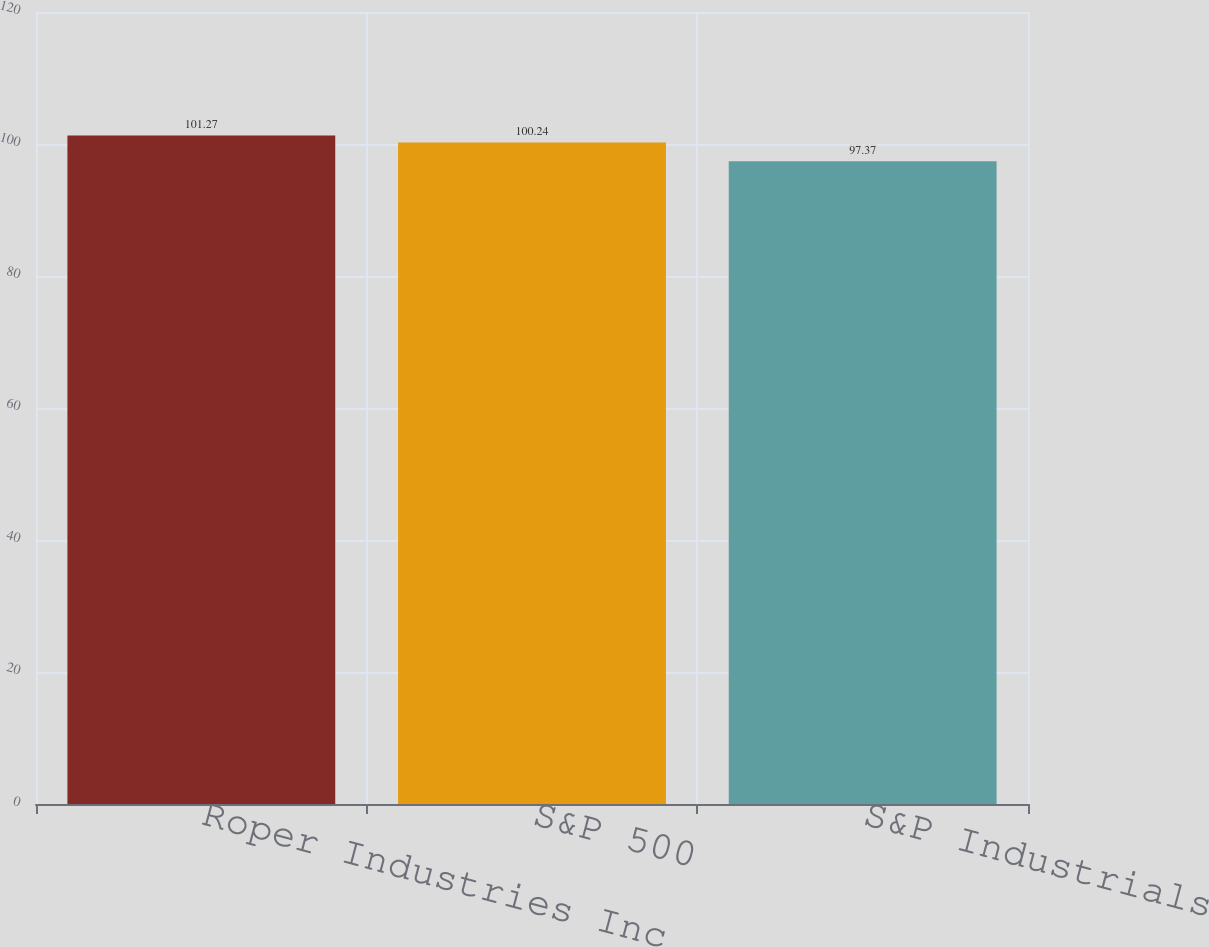Convert chart. <chart><loc_0><loc_0><loc_500><loc_500><bar_chart><fcel>Roper Industries Inc<fcel>S&P 500<fcel>S&P Industrials<nl><fcel>101.27<fcel>100.24<fcel>97.37<nl></chart> 